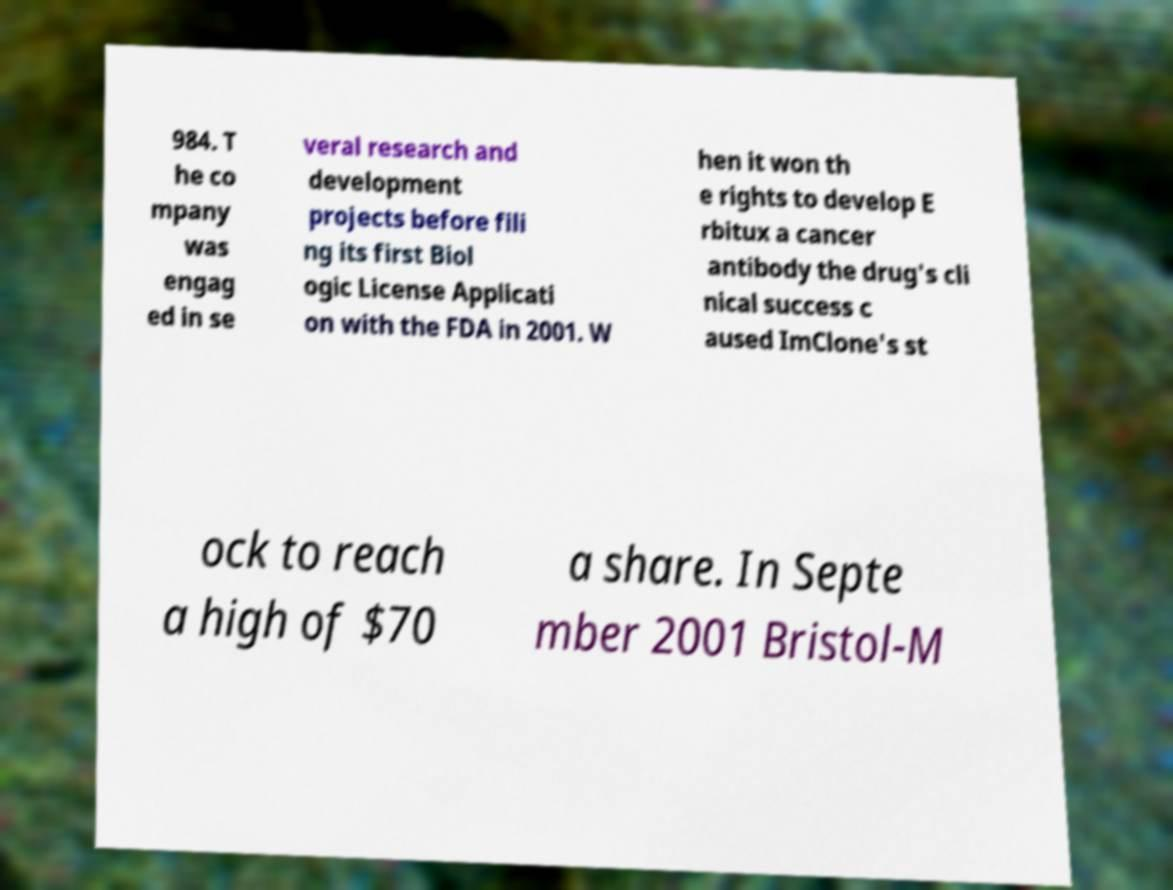For documentation purposes, I need the text within this image transcribed. Could you provide that? 984. T he co mpany was engag ed in se veral research and development projects before fili ng its first Biol ogic License Applicati on with the FDA in 2001. W hen it won th e rights to develop E rbitux a cancer antibody the drug's cli nical success c aused ImClone's st ock to reach a high of $70 a share. In Septe mber 2001 Bristol-M 